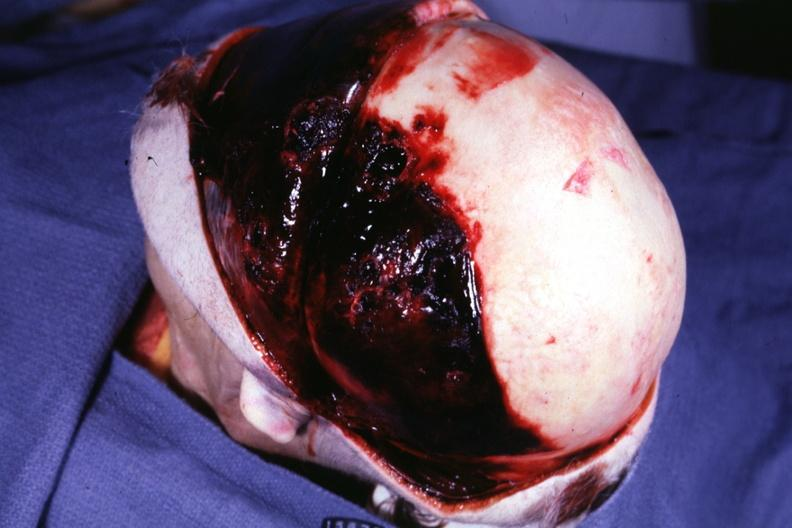what does this protocol have?
Answer the question using a single word or phrase. Basal skull fracture chronic subdural hematoma malignant lymphoma and acute myelogenous leukemia 